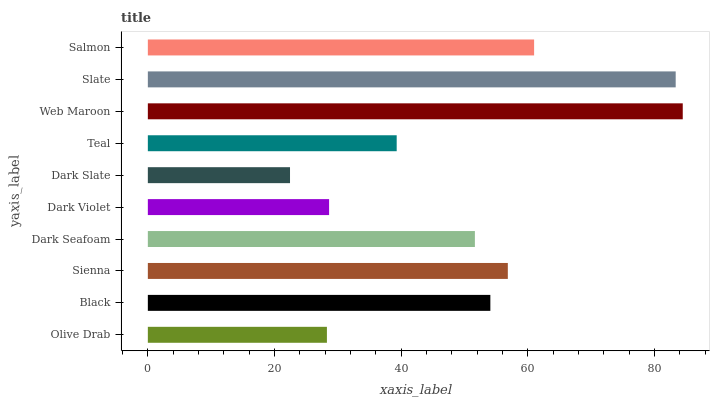Is Dark Slate the minimum?
Answer yes or no. Yes. Is Web Maroon the maximum?
Answer yes or no. Yes. Is Black the minimum?
Answer yes or no. No. Is Black the maximum?
Answer yes or no. No. Is Black greater than Olive Drab?
Answer yes or no. Yes. Is Olive Drab less than Black?
Answer yes or no. Yes. Is Olive Drab greater than Black?
Answer yes or no. No. Is Black less than Olive Drab?
Answer yes or no. No. Is Black the high median?
Answer yes or no. Yes. Is Dark Seafoam the low median?
Answer yes or no. Yes. Is Salmon the high median?
Answer yes or no. No. Is Dark Slate the low median?
Answer yes or no. No. 